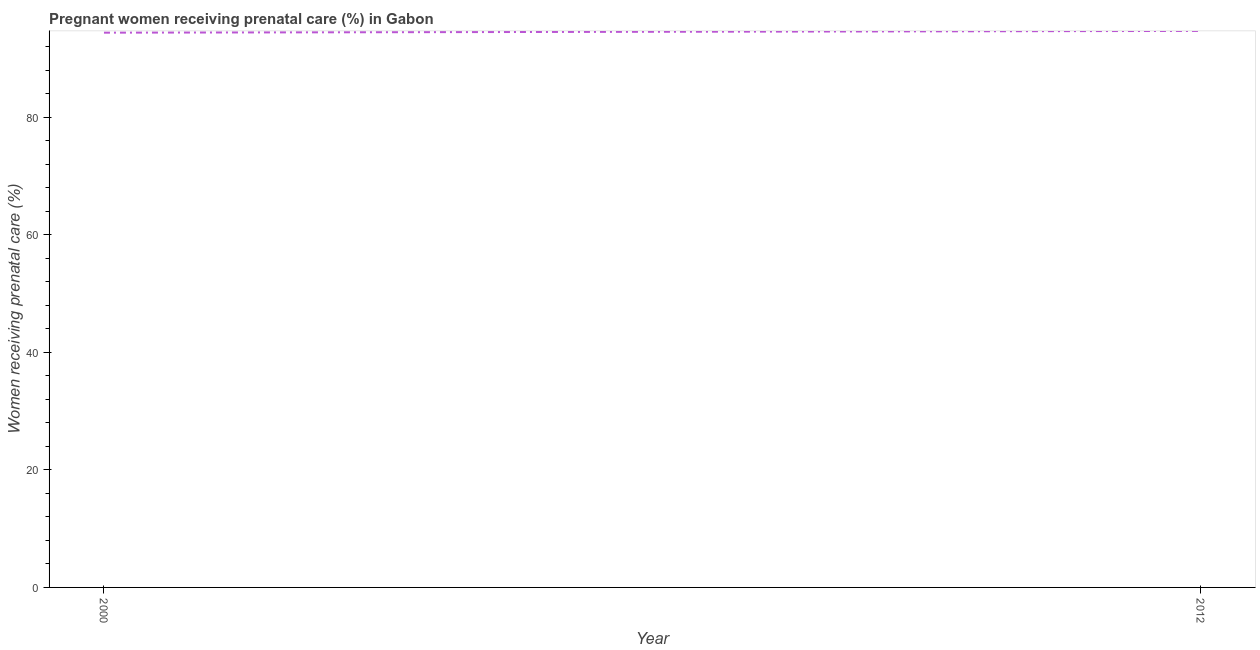What is the percentage of pregnant women receiving prenatal care in 2000?
Offer a terse response. 94.4. Across all years, what is the maximum percentage of pregnant women receiving prenatal care?
Keep it short and to the point. 94.7. Across all years, what is the minimum percentage of pregnant women receiving prenatal care?
Make the answer very short. 94.4. In which year was the percentage of pregnant women receiving prenatal care maximum?
Your answer should be compact. 2012. What is the sum of the percentage of pregnant women receiving prenatal care?
Your response must be concise. 189.1. What is the difference between the percentage of pregnant women receiving prenatal care in 2000 and 2012?
Give a very brief answer. -0.3. What is the average percentage of pregnant women receiving prenatal care per year?
Provide a succinct answer. 94.55. What is the median percentage of pregnant women receiving prenatal care?
Ensure brevity in your answer.  94.55. Do a majority of the years between 2000 and 2012 (inclusive) have percentage of pregnant women receiving prenatal care greater than 64 %?
Your response must be concise. Yes. What is the ratio of the percentage of pregnant women receiving prenatal care in 2000 to that in 2012?
Offer a terse response. 1. Does the percentage of pregnant women receiving prenatal care monotonically increase over the years?
Your response must be concise. Yes. How many lines are there?
Give a very brief answer. 1. Are the values on the major ticks of Y-axis written in scientific E-notation?
Ensure brevity in your answer.  No. Does the graph contain any zero values?
Offer a very short reply. No. Does the graph contain grids?
Make the answer very short. No. What is the title of the graph?
Offer a terse response. Pregnant women receiving prenatal care (%) in Gabon. What is the label or title of the Y-axis?
Your answer should be compact. Women receiving prenatal care (%). What is the Women receiving prenatal care (%) in 2000?
Your answer should be very brief. 94.4. What is the Women receiving prenatal care (%) in 2012?
Provide a short and direct response. 94.7. What is the difference between the Women receiving prenatal care (%) in 2000 and 2012?
Your answer should be very brief. -0.3. What is the ratio of the Women receiving prenatal care (%) in 2000 to that in 2012?
Provide a succinct answer. 1. 